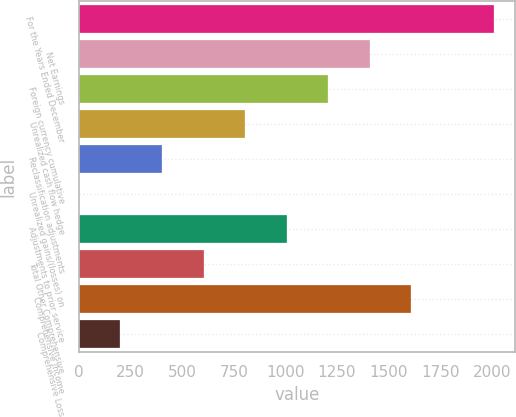Convert chart. <chart><loc_0><loc_0><loc_500><loc_500><bar_chart><fcel>For the Years Ended December<fcel>Net Earnings<fcel>Foreign currency cumulative<fcel>Unrealized cash flow hedge<fcel>Reclassification adjustments<fcel>Unrealized gains/(losses) on<fcel>Adjustments to prior service<fcel>Total Other Comprehensive<fcel>Comprehensive Income<fcel>Comprehensive Loss<nl><fcel>2013<fcel>1409.13<fcel>1207.84<fcel>805.26<fcel>402.68<fcel>0.1<fcel>1006.55<fcel>603.97<fcel>1610.42<fcel>201.39<nl></chart> 